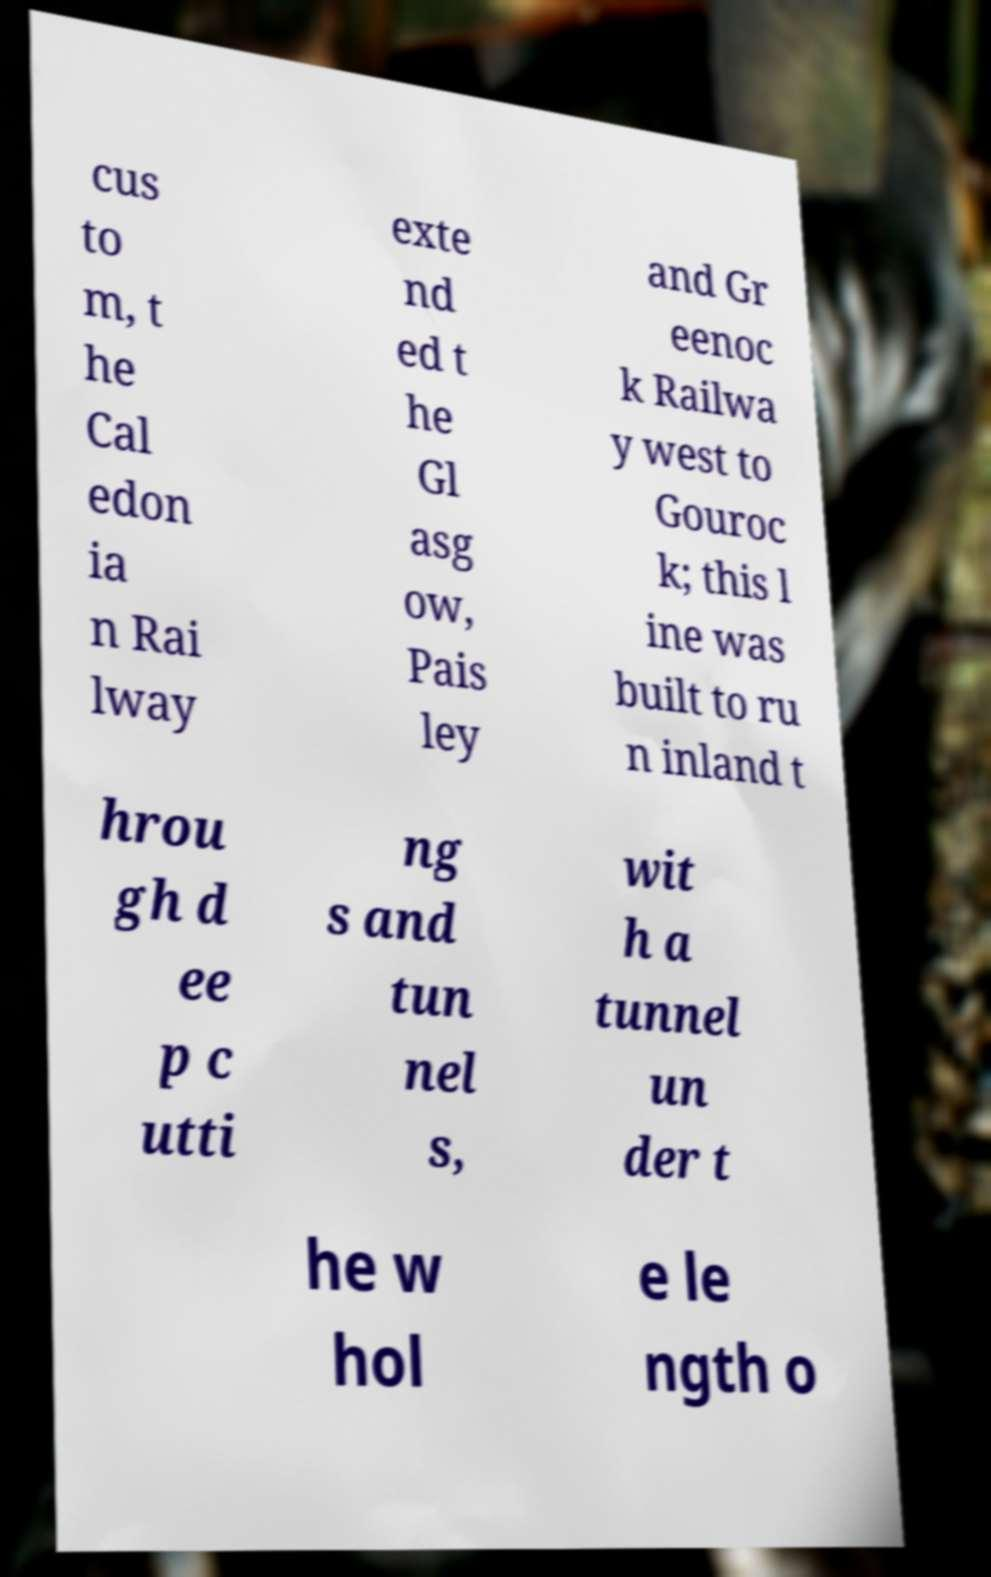Can you read and provide the text displayed in the image?This photo seems to have some interesting text. Can you extract and type it out for me? cus to m, t he Cal edon ia n Rai lway exte nd ed t he Gl asg ow, Pais ley and Gr eenoc k Railwa y west to Gouroc k; this l ine was built to ru n inland t hrou gh d ee p c utti ng s and tun nel s, wit h a tunnel un der t he w hol e le ngth o 